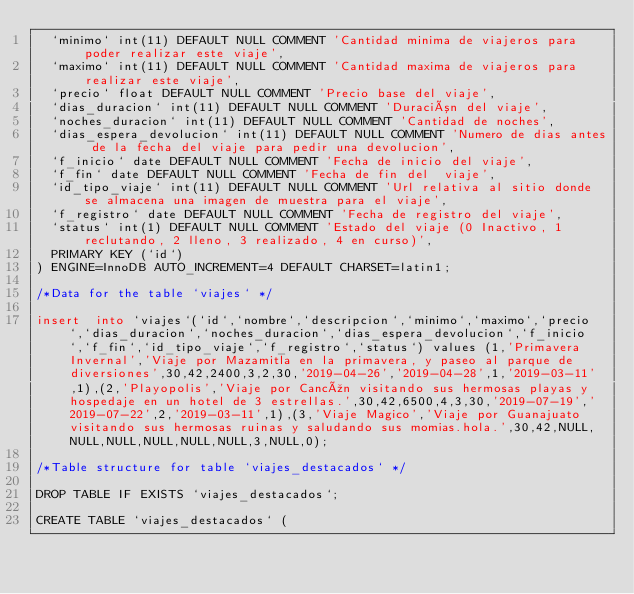<code> <loc_0><loc_0><loc_500><loc_500><_SQL_>  `minimo` int(11) DEFAULT NULL COMMENT 'Cantidad minima de viajeros para poder realizar este viaje',
  `maximo` int(11) DEFAULT NULL COMMENT 'Cantidad maxima de viajeros para realizar este viaje',
  `precio` float DEFAULT NULL COMMENT 'Precio base del viaje',
  `dias_duracion` int(11) DEFAULT NULL COMMENT 'Duración del viaje',
  `noches_duracion` int(11) DEFAULT NULL COMMENT 'Cantidad de noches',
  `dias_espera_devolucion` int(11) DEFAULT NULL COMMENT 'Numero de dias antes de la fecha del viaje para pedir una devolucion',
  `f_inicio` date DEFAULT NULL COMMENT 'Fecha de inicio del viaje',
  `f_fin` date DEFAULT NULL COMMENT 'Fecha de fin del  viaje',
  `id_tipo_viaje` int(11) DEFAULT NULL COMMENT 'Url relativa al sitio donde se almacena una imagen de muestra para el viaje',
  `f_registro` date DEFAULT NULL COMMENT 'Fecha de registro del viaje',
  `status` int(1) DEFAULT NULL COMMENT 'Estado del viaje (0 Inactivo, 1 reclutando, 2 lleno, 3 realizado, 4 en curso)',
  PRIMARY KEY (`id`)
) ENGINE=InnoDB AUTO_INCREMENT=4 DEFAULT CHARSET=latin1;

/*Data for the table `viajes` */

insert  into `viajes`(`id`,`nombre`,`descripcion`,`minimo`,`maximo`,`precio`,`dias_duracion`,`noches_duracion`,`dias_espera_devolucion`,`f_inicio`,`f_fin`,`id_tipo_viaje`,`f_registro`,`status`) values (1,'Primavera Invernal','Viaje por Mazamitla en la primavera, y paseo al parque de diversiones',30,42,2400,3,2,30,'2019-04-26','2019-04-28',1,'2019-03-11',1),(2,'Playopolis','Viaje por Cancún visitando sus hermosas playas y hospedaje en un hotel de 3 estrellas.',30,42,6500,4,3,30,'2019-07-19','2019-07-22',2,'2019-03-11',1),(3,'Viaje Magico','Viaje por Guanajuato visitando sus hermosas ruinas y saludando sus momias.hola.',30,42,NULL,NULL,NULL,NULL,NULL,NULL,3,NULL,0);

/*Table structure for table `viajes_destacados` */

DROP TABLE IF EXISTS `viajes_destacados`;

CREATE TABLE `viajes_destacados` (</code> 